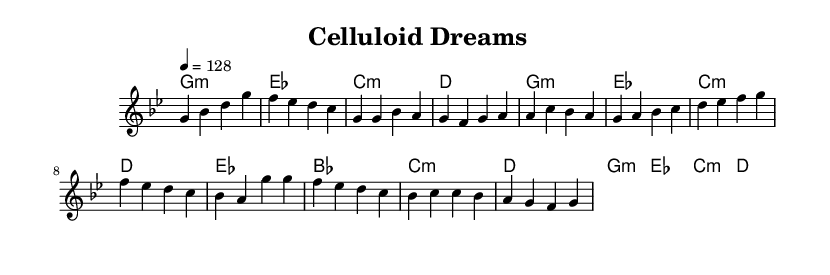What is the key signature of this music? The key signature is G minor, which has two flats (B♭ and E♭). It is indicated at the beginning of the sheet music within the global settings under the key statement.
Answer: G minor What is the time signature of the music? The time signature is 4/4, which means there are four beats in a measure and a quarter note gets one beat. This is also indicated in the global settings at the start of the sheet music.
Answer: 4/4 What is the tempo marking of this piece? The tempo is marked at 4 = 128, indicating that there are 128 beats per minute. This tempo directs musicians on how fast to play the piece and can be found in the global context of the score.
Answer: 128 How many measures are present in the melody part provided? The melody section contains a total of 12 measures, which can be counted by observing the notated bars on the sheet music. Each vertical line represents a measure.
Answer: 12 What is the chord progression for the verses? The chord progression for the verses is G minor, E♭ major, C minor, D major. This is outlined in the harmonies section and follows a consistent pattern throughout the verse.
Answer: G minor, E♭ major, C minor, D major How many distinct musical sections are indicated in the score? The score indicates four distinct sections: Intro, Verse 1, Pre-Chorus, and Chorus. This structure helps define the flow and development of the song and is noted in the organization of the melody and chord changes.
Answer: Four 